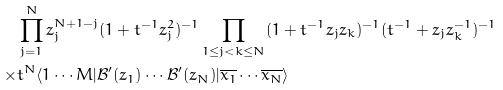<formula> <loc_0><loc_0><loc_500><loc_500>& \prod _ { j = 1 } ^ { N } z _ { j } ^ { N + 1 - j } ( 1 + t ^ { - 1 } z _ { j } ^ { 2 } ) ^ { - 1 } \prod _ { 1 \leq j < k \leq N } ( 1 + t ^ { - 1 } z _ { j } z _ { k } ) ^ { - 1 } ( t ^ { - 1 } + z _ { j } z _ { k } ^ { - 1 } ) ^ { - 1 } \\ \times & t ^ { N } \langle 1 \cdots M | \mathcal { B } ^ { \prime } ( z _ { 1 } ) \cdots \mathcal { B } ^ { \prime } ( z _ { N } ) | \overline { x _ { 1 } } \cdots \overline { x _ { N } } \rangle</formula> 